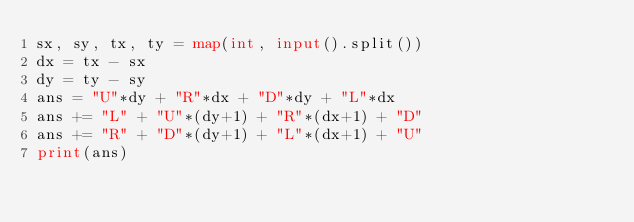Convert code to text. <code><loc_0><loc_0><loc_500><loc_500><_Python_>sx, sy, tx, ty = map(int, input().split())
dx = tx - sx
dy = ty - sy
ans = "U"*dy + "R"*dx + "D"*dy + "L"*dx
ans += "L" + "U"*(dy+1) + "R"*(dx+1) + "D"
ans += "R" + "D"*(dy+1) + "L"*(dx+1) + "U"
print(ans)</code> 